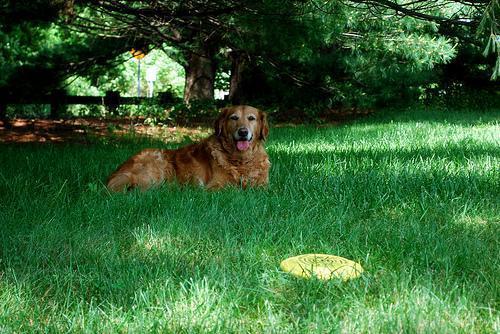How many dog are there?
Give a very brief answer. 1. How many dogs are there?
Give a very brief answer. 1. How many frisbees are there?
Give a very brief answer. 1. 